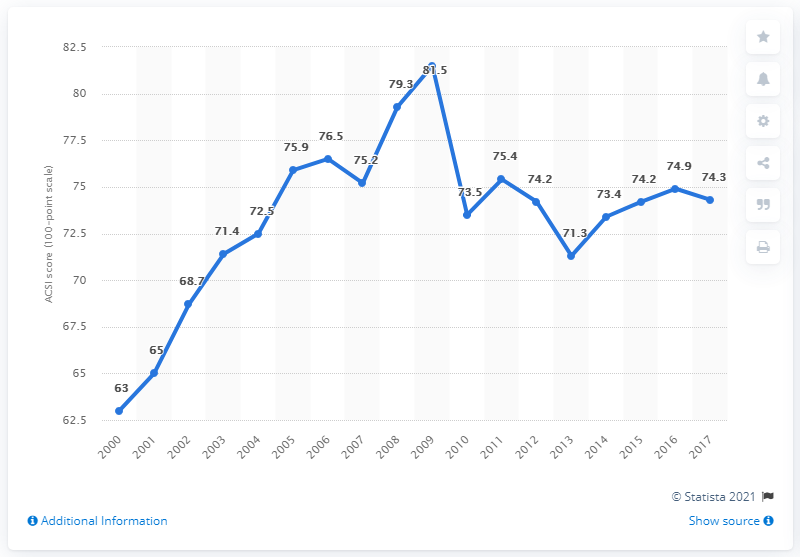Can you tell me more about the context surrounding the sharp increase in customer satisfaction leading up to 2011? While the chart does not provide specific details about the factors contributing to the sharp rise in customer satisfaction, it might suggest that businesses were embracing new technologies, improving their e-business platforms, or enhancing customer service practices. This period could correlate with advancements in internet services and increased customer familiarity with e-commerce, leading to better satisfaction up to 2011.  How might the dip in 2012 be explained? The dip in 2012 might be attributed to various factors such as economic downturns, changes in consumer expectations, cyber-security incidents, or perhaps dissatisfaction with user experiences on e-business platforms. Businesses might have faced challenges in scaling their operations to meet increasing demand or maintaining high service standards. 